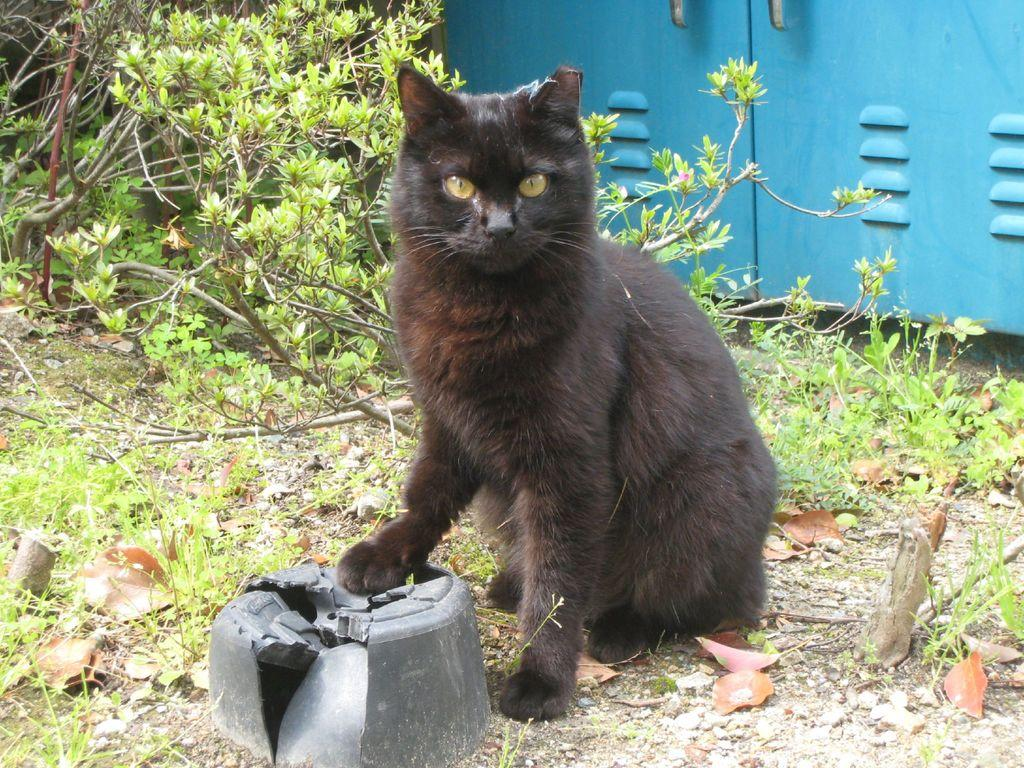What type of animal can be seen in the image? There is a black cat in the image. What natural elements are visible in the image? Trees and grass on the ground are visible in the image. What object can be seen on the side in the image? There is a metal box on the side in the image. What type of tent is set up in the image? There is no tent present in the image. How many spiders can be seen crawling on the black cat in the image? A: There are no spiders visible in the image; it only features a black cat. 